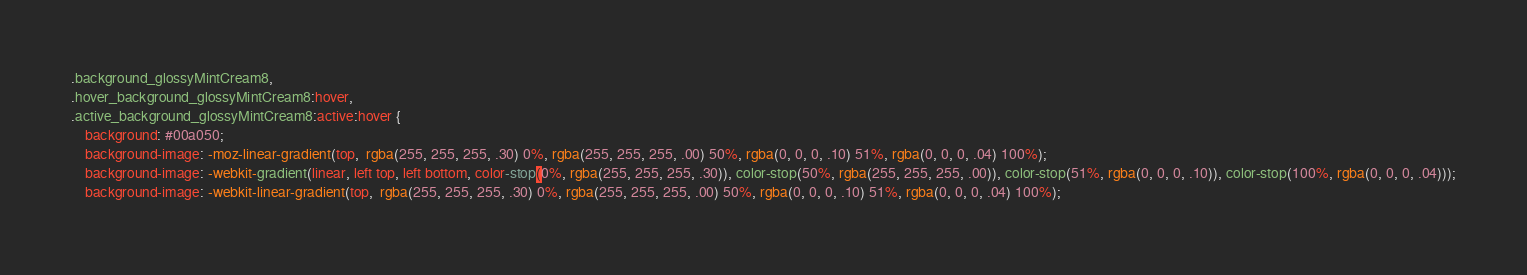<code> <loc_0><loc_0><loc_500><loc_500><_CSS_>.background_glossyMintCream8,
.hover_background_glossyMintCream8:hover,
.active_background_glossyMintCream8:active:hover {
    background: #00a050;
    background-image: -moz-linear-gradient(top,  rgba(255, 255, 255, .30) 0%, rgba(255, 255, 255, .00) 50%, rgba(0, 0, 0, .10) 51%, rgba(0, 0, 0, .04) 100%);
    background-image: -webkit-gradient(linear, left top, left bottom, color-stop(0%, rgba(255, 255, 255, .30)), color-stop(50%, rgba(255, 255, 255, .00)), color-stop(51%, rgba(0, 0, 0, .10)), color-stop(100%, rgba(0, 0, 0, .04)));
    background-image: -webkit-linear-gradient(top,  rgba(255, 255, 255, .30) 0%, rgba(255, 255, 255, .00) 50%, rgba(0, 0, 0, .10) 51%, rgba(0, 0, 0, .04) 100%);</code> 